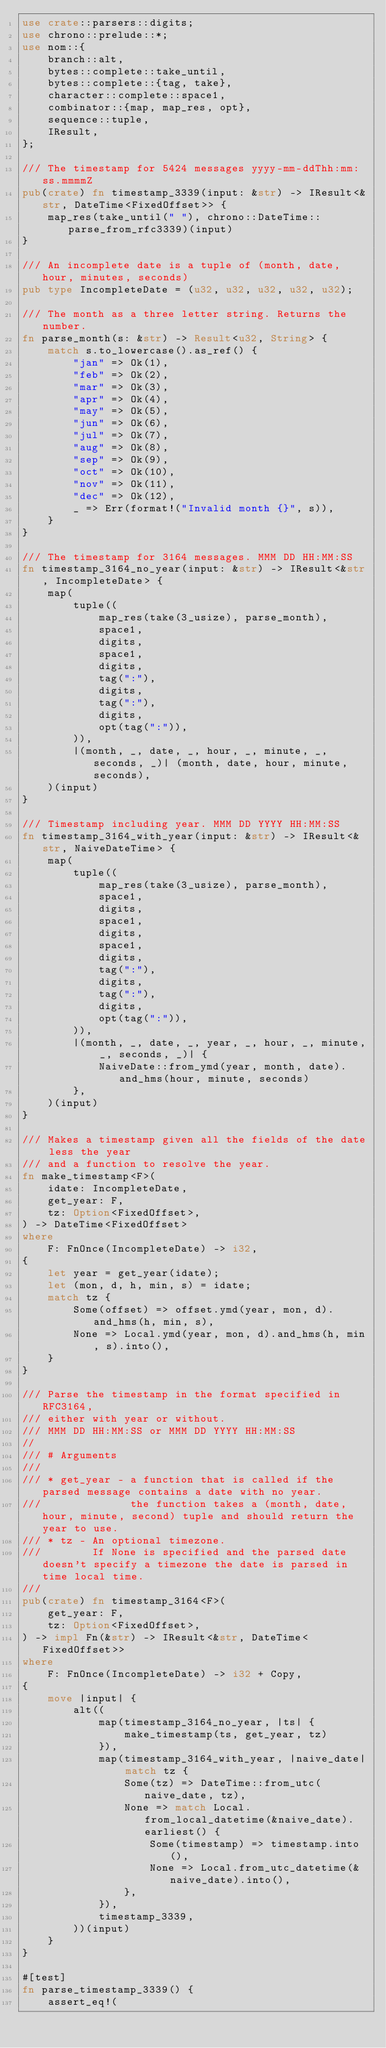<code> <loc_0><loc_0><loc_500><loc_500><_Rust_>use crate::parsers::digits;
use chrono::prelude::*;
use nom::{
    branch::alt,
    bytes::complete::take_until,
    bytes::complete::{tag, take},
    character::complete::space1,
    combinator::{map, map_res, opt},
    sequence::tuple,
    IResult,
};

/// The timestamp for 5424 messages yyyy-mm-ddThh:mm:ss.mmmmZ
pub(crate) fn timestamp_3339(input: &str) -> IResult<&str, DateTime<FixedOffset>> {
    map_res(take_until(" "), chrono::DateTime::parse_from_rfc3339)(input)
}

/// An incomplete date is a tuple of (month, date, hour, minutes, seconds)
pub type IncompleteDate = (u32, u32, u32, u32, u32);

/// The month as a three letter string. Returns the number.
fn parse_month(s: &str) -> Result<u32, String> {
    match s.to_lowercase().as_ref() {
        "jan" => Ok(1),
        "feb" => Ok(2),
        "mar" => Ok(3),
        "apr" => Ok(4),
        "may" => Ok(5),
        "jun" => Ok(6),
        "jul" => Ok(7),
        "aug" => Ok(8),
        "sep" => Ok(9),
        "oct" => Ok(10),
        "nov" => Ok(11),
        "dec" => Ok(12),
        _ => Err(format!("Invalid month {}", s)),
    }
}

/// The timestamp for 3164 messages. MMM DD HH:MM:SS
fn timestamp_3164_no_year(input: &str) -> IResult<&str, IncompleteDate> {
    map(
        tuple((
            map_res(take(3_usize), parse_month),
            space1,
            digits,
            space1,
            digits,
            tag(":"),
            digits,
            tag(":"),
            digits,
            opt(tag(":")),
        )),
        |(month, _, date, _, hour, _, minute, _, seconds, _)| (month, date, hour, minute, seconds),
    )(input)
}

/// Timestamp including year. MMM DD YYYY HH:MM:SS
fn timestamp_3164_with_year(input: &str) -> IResult<&str, NaiveDateTime> {
    map(
        tuple((
            map_res(take(3_usize), parse_month),
            space1,
            digits,
            space1,
            digits,
            space1,
            digits,
            tag(":"),
            digits,
            tag(":"),
            digits,
            opt(tag(":")),
        )),
        |(month, _, date, _, year, _, hour, _, minute, _, seconds, _)| {
            NaiveDate::from_ymd(year, month, date).and_hms(hour, minute, seconds)
        },
    )(input)
}

/// Makes a timestamp given all the fields of the date less the year
/// and a function to resolve the year.
fn make_timestamp<F>(
    idate: IncompleteDate,
    get_year: F,
    tz: Option<FixedOffset>,
) -> DateTime<FixedOffset>
where
    F: FnOnce(IncompleteDate) -> i32,
{
    let year = get_year(idate);
    let (mon, d, h, min, s) = idate;
    match tz {
        Some(offset) => offset.ymd(year, mon, d).and_hms(h, min, s),
        None => Local.ymd(year, mon, d).and_hms(h, min, s).into(),
    }
}

/// Parse the timestamp in the format specified in RFC3164,
/// either with year or without.
/// MMM DD HH:MM:SS or MMM DD YYYY HH:MM:SS
//
/// # Arguments
///
/// * get_year - a function that is called if the parsed message contains a date with no year.
///              the function takes a (month, date, hour, minute, second) tuple and should return the year to use.
/// * tz - An optional timezone.
///        If None is specified and the parsed date doesn't specify a timezone the date is parsed in time local time.
///
pub(crate) fn timestamp_3164<F>(
    get_year: F,
    tz: Option<FixedOffset>,
) -> impl Fn(&str) -> IResult<&str, DateTime<FixedOffset>>
where
    F: FnOnce(IncompleteDate) -> i32 + Copy,
{
    move |input| {
        alt((
            map(timestamp_3164_no_year, |ts| {
                make_timestamp(ts, get_year, tz)
            }),
            map(timestamp_3164_with_year, |naive_date| match tz {
                Some(tz) => DateTime::from_utc(naive_date, tz),
                None => match Local.from_local_datetime(&naive_date).earliest() {
                    Some(timestamp) => timestamp.into(),
                    None => Local.from_utc_datetime(&naive_date).into(),
                },
            }),
            timestamp_3339,
        ))(input)
    }
}

#[test]
fn parse_timestamp_3339() {
    assert_eq!(</code> 